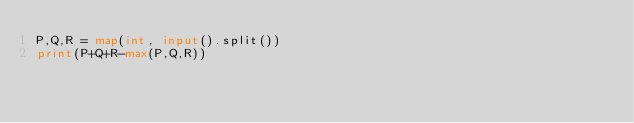Convert code to text. <code><loc_0><loc_0><loc_500><loc_500><_Python_>P,Q,R = map(int, input().split())
print(P+Q+R-max(P,Q,R))</code> 